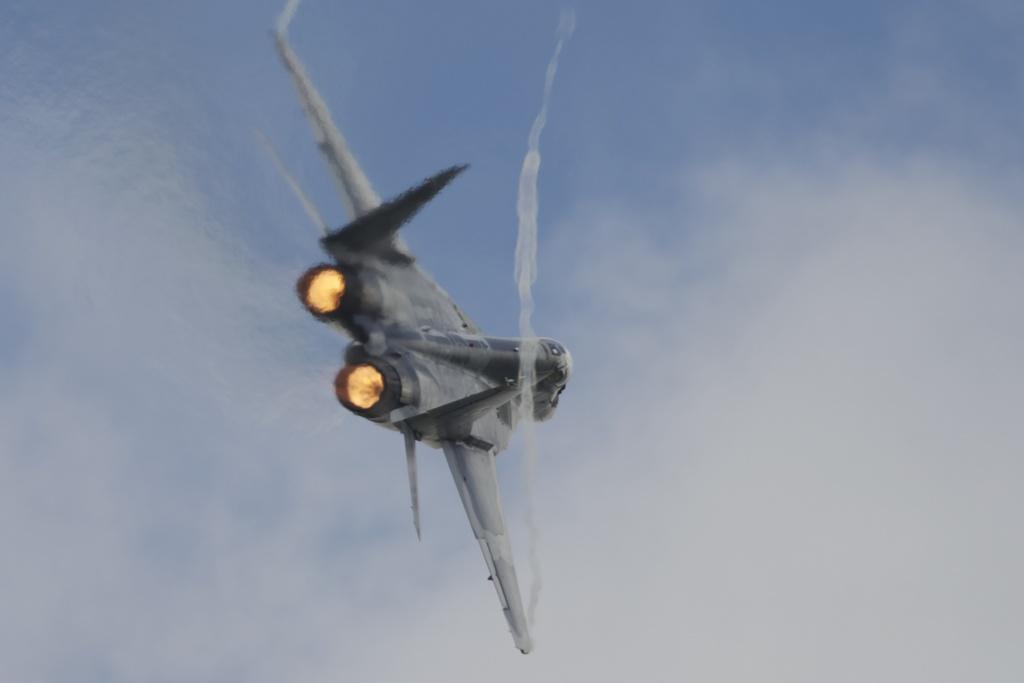What is the main subject of the image? The main subject of the image is an airplane. Can you describe the position of the airplane in the image? The airplane is in the air. What can be seen coming from the airplane in the image? There is smoke visible in the image. What is visible in the background of the image? The sky is visible in the background of the image. What can be observed in the sky in the image? Clouds are present in the sky. Where is the bead market located in the image? There is no bead market present in the image; it features an airplane in the sky. What type of heat source can be seen in the image? There is no heat source visible in the image. 